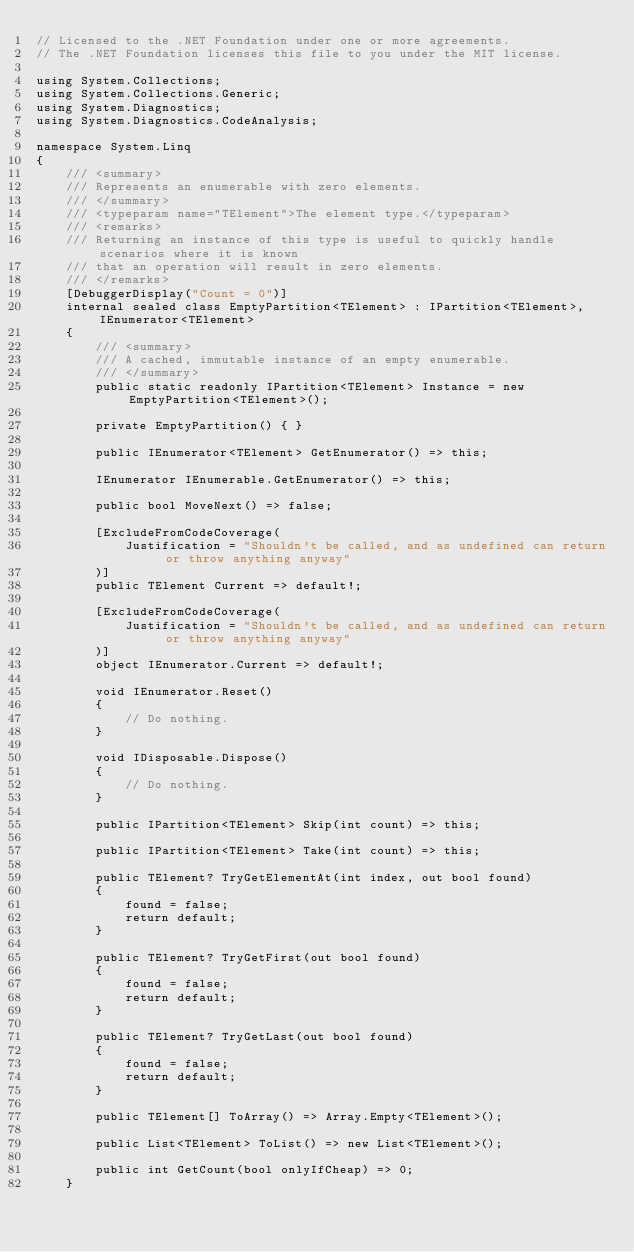<code> <loc_0><loc_0><loc_500><loc_500><_C#_>// Licensed to the .NET Foundation under one or more agreements.
// The .NET Foundation licenses this file to you under the MIT license.

using System.Collections;
using System.Collections.Generic;
using System.Diagnostics;
using System.Diagnostics.CodeAnalysis;

namespace System.Linq
{
    /// <summary>
    /// Represents an enumerable with zero elements.
    /// </summary>
    /// <typeparam name="TElement">The element type.</typeparam>
    /// <remarks>
    /// Returning an instance of this type is useful to quickly handle scenarios where it is known
    /// that an operation will result in zero elements.
    /// </remarks>
    [DebuggerDisplay("Count = 0")]
    internal sealed class EmptyPartition<TElement> : IPartition<TElement>, IEnumerator<TElement>
    {
        /// <summary>
        /// A cached, immutable instance of an empty enumerable.
        /// </summary>
        public static readonly IPartition<TElement> Instance = new EmptyPartition<TElement>();

        private EmptyPartition() { }

        public IEnumerator<TElement> GetEnumerator() => this;

        IEnumerator IEnumerable.GetEnumerator() => this;

        public bool MoveNext() => false;

        [ExcludeFromCodeCoverage(
            Justification = "Shouldn't be called, and as undefined can return or throw anything anyway"
        )]
        public TElement Current => default!;

        [ExcludeFromCodeCoverage(
            Justification = "Shouldn't be called, and as undefined can return or throw anything anyway"
        )]
        object IEnumerator.Current => default!;

        void IEnumerator.Reset()
        {
            // Do nothing.
        }

        void IDisposable.Dispose()
        {
            // Do nothing.
        }

        public IPartition<TElement> Skip(int count) => this;

        public IPartition<TElement> Take(int count) => this;

        public TElement? TryGetElementAt(int index, out bool found)
        {
            found = false;
            return default;
        }

        public TElement? TryGetFirst(out bool found)
        {
            found = false;
            return default;
        }

        public TElement? TryGetLast(out bool found)
        {
            found = false;
            return default;
        }

        public TElement[] ToArray() => Array.Empty<TElement>();

        public List<TElement> ToList() => new List<TElement>();

        public int GetCount(bool onlyIfCheap) => 0;
    }
</code> 